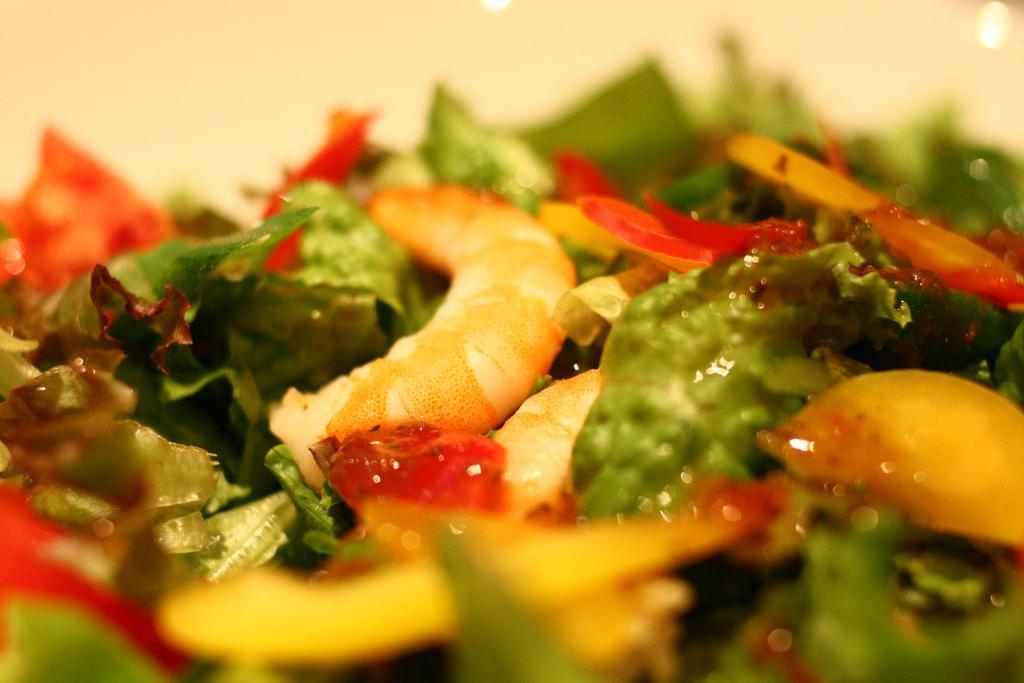What type of food items can be seen in the image? The food items in the image include green leafy vegetables. Are there any other items present with the green leafy vegetables? Yes, there are other items present with the green leafy vegetables. Where are the food items located in the image? The food items are in the center of the image. Can you see a basin filled with men using quills in the image? No, there is no basin filled with men using quills in the image. 